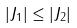Convert formula to latex. <formula><loc_0><loc_0><loc_500><loc_500>| J _ { 1 } | \leq | J _ { 2 } |</formula> 